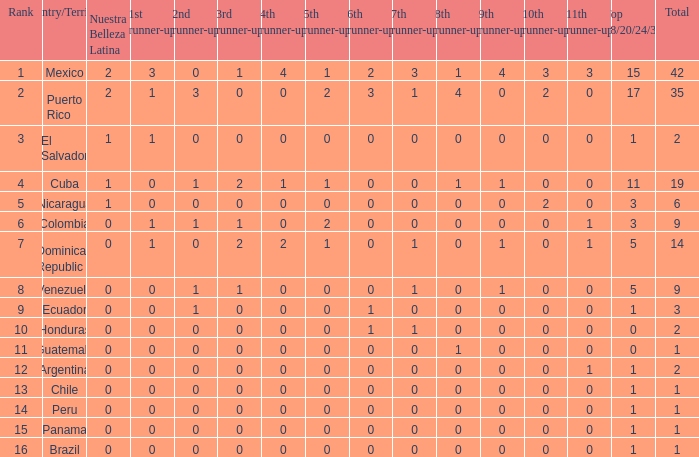Help me parse the entirety of this table. {'header': ['Rank', 'Country/Territory', 'Nuestra Belleza Latina', '1st runner-up', '2nd runner-up', '3rd runner-up', '4th runner-up', '5th runner-up', '6th runner-up', '7th runner-up', '8th runner-up', '9th runner-up', '10th runner-up', '11th runner-up', 'Top 18/20/24/30', 'Total'], 'rows': [['1', 'Mexico', '2', '3', '0', '1', '4', '1', '2', '3', '1', '4', '3', '3', '15', '42'], ['2', 'Puerto Rico', '2', '1', '3', '0', '0', '2', '3', '1', '4', '0', '2', '0', '17', '35'], ['3', 'El Salvador', '1', '1', '0', '0', '0', '0', '0', '0', '0', '0', '0', '0', '1', '2'], ['4', 'Cuba', '1', '0', '1', '2', '1', '1', '0', '0', '1', '1', '0', '0', '11', '19'], ['5', 'Nicaragua', '1', '0', '0', '0', '0', '0', '0', '0', '0', '0', '2', '0', '3', '6'], ['6', 'Colombia', '0', '1', '1', '1', '0', '2', '0', '0', '0', '0', '0', '1', '3', '9'], ['7', 'Dominican Republic', '0', '1', '0', '2', '2', '1', '0', '1', '0', '1', '0', '1', '5', '14'], ['8', 'Venezuela', '0', '0', '1', '1', '0', '0', '0', '1', '0', '1', '0', '0', '5', '9'], ['9', 'Ecuador', '0', '0', '1', '0', '0', '0', '1', '0', '0', '0', '0', '0', '1', '3'], ['10', 'Honduras', '0', '0', '0', '0', '0', '0', '1', '1', '0', '0', '0', '0', '0', '2'], ['11', 'Guatemala', '0', '0', '0', '0', '0', '0', '0', '0', '1', '0', '0', '0', '0', '1'], ['12', 'Argentina', '0', '0', '0', '0', '0', '0', '0', '0', '0', '0', '0', '1', '1', '2'], ['13', 'Chile', '0', '0', '0', '0', '0', '0', '0', '0', '0', '0', '0', '0', '1', '1'], ['14', 'Peru', '0', '0', '0', '0', '0', '0', '0', '0', '0', '0', '0', '0', '1', '1'], ['15', 'Panama', '0', '0', '0', '0', '0', '0', '0', '0', '0', '0', '0', '0', '1', '1'], ['16', 'Brazil', '0', '0', '0', '0', '0', '0', '0', '0', '0', '0', '0', '0', '1', '1']]} What is the 3rd runner-up of the country with more than 0 9th runner-up, an 11th runner-up of 0, and the 1st runner-up greater than 0? None. 